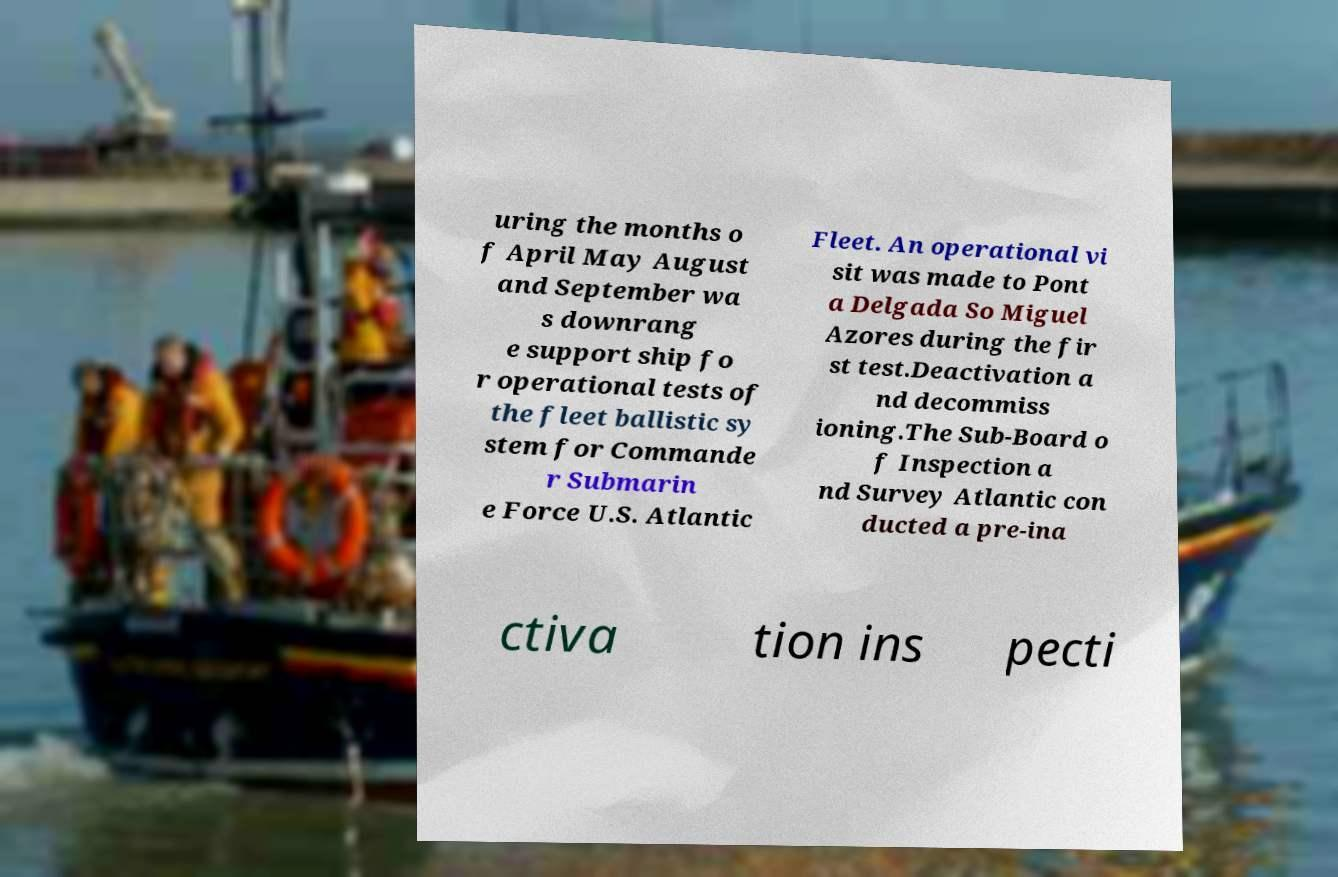There's text embedded in this image that I need extracted. Can you transcribe it verbatim? uring the months o f April May August and September wa s downrang e support ship fo r operational tests of the fleet ballistic sy stem for Commande r Submarin e Force U.S. Atlantic Fleet. An operational vi sit was made to Pont a Delgada So Miguel Azores during the fir st test.Deactivation a nd decommiss ioning.The Sub-Board o f Inspection a nd Survey Atlantic con ducted a pre-ina ctiva tion ins pecti 